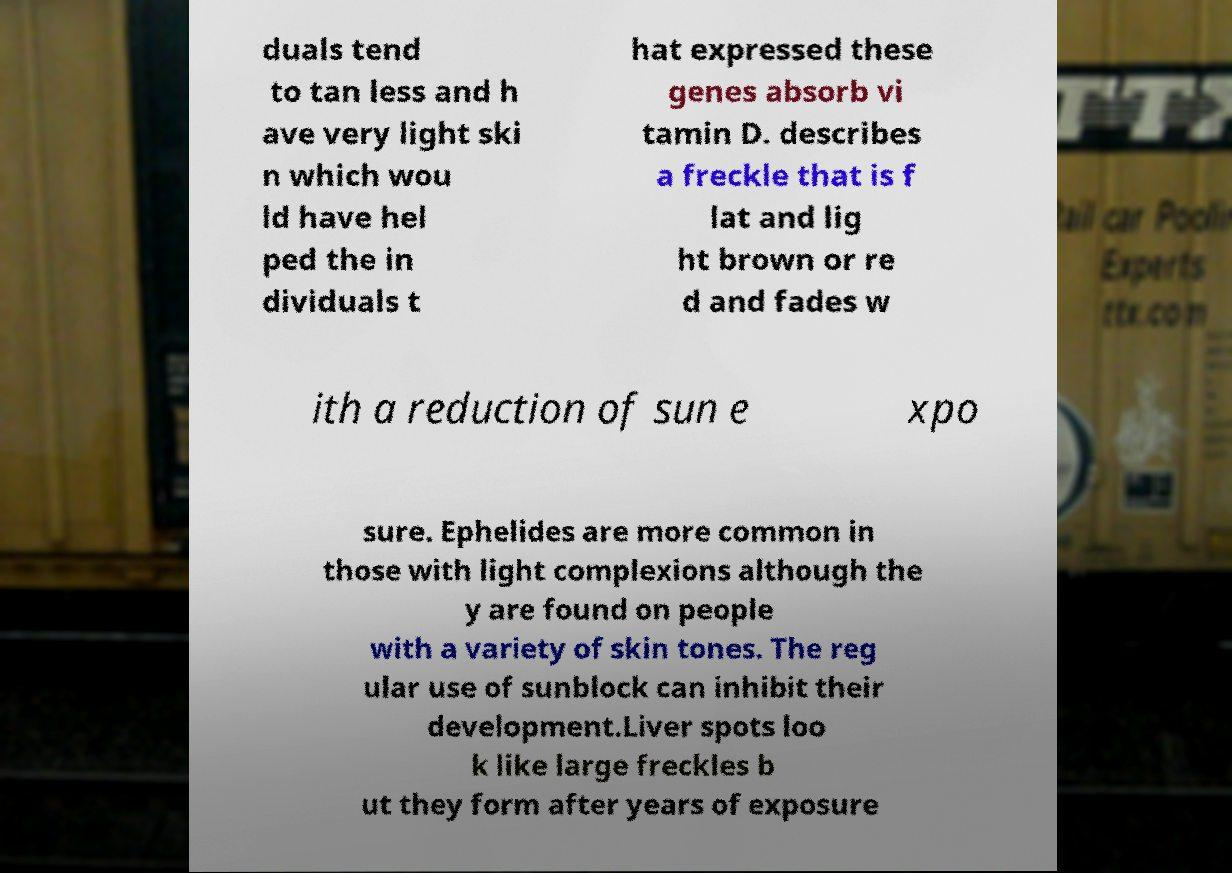There's text embedded in this image that I need extracted. Can you transcribe it verbatim? duals tend to tan less and h ave very light ski n which wou ld have hel ped the in dividuals t hat expressed these genes absorb vi tamin D. describes a freckle that is f lat and lig ht brown or re d and fades w ith a reduction of sun e xpo sure. Ephelides are more common in those with light complexions although the y are found on people with a variety of skin tones. The reg ular use of sunblock can inhibit their development.Liver spots loo k like large freckles b ut they form after years of exposure 